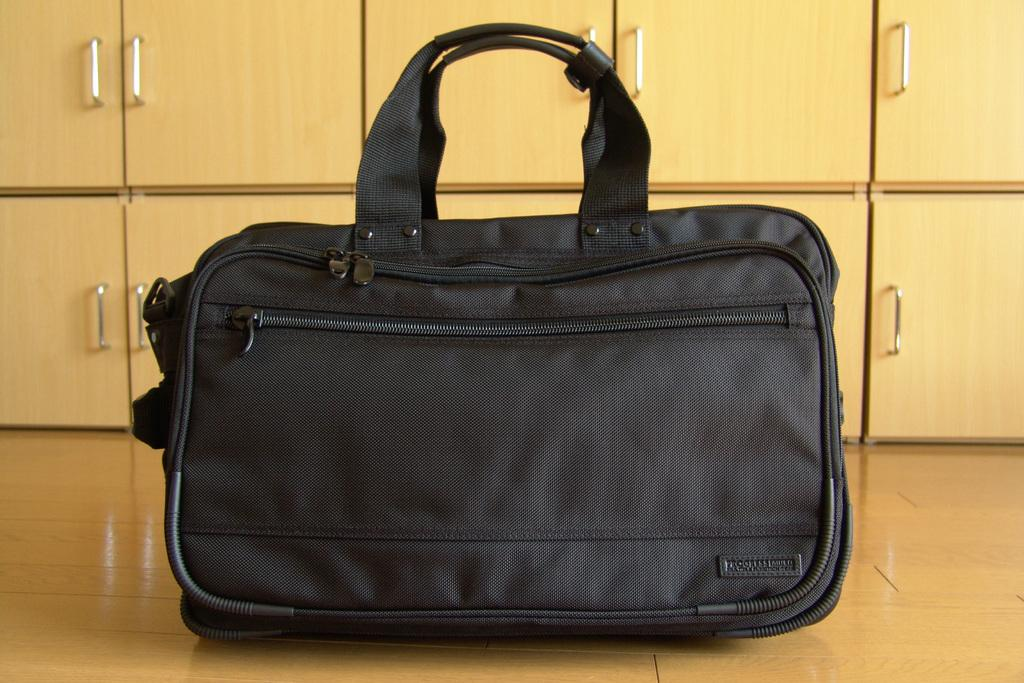What color is the bag that is visible in the image? The bag in the image is black colored. What can be seen in the background of the image? There are cupboards in the background of the image. How many cattle are present in the image? There are no cattle present in the image. What type of frame surrounds the image? The provided facts do not mention any frame surrounding the image. 